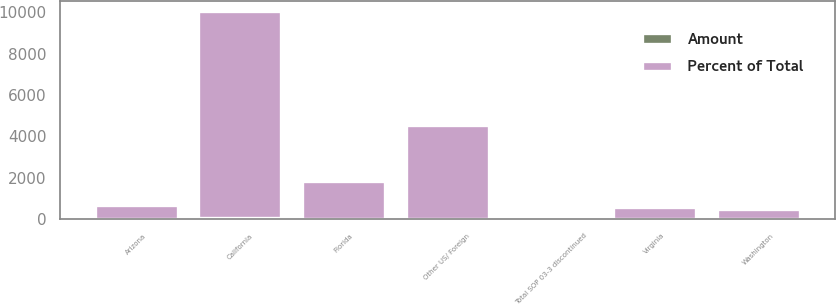<chart> <loc_0><loc_0><loc_500><loc_500><stacked_bar_chart><ecel><fcel>California<fcel>Florida<fcel>Arizona<fcel>Virginia<fcel>Washington<fcel>Other US/ Foreign<fcel>Total SOP 03-3 discontinued<nl><fcel>Percent of Total<fcel>9987<fcel>1831<fcel>666<fcel>580<fcel>492<fcel>4541<fcel>100<nl><fcel>Amount<fcel>55.2<fcel>10.1<fcel>3.7<fcel>3.2<fcel>2.7<fcel>25.1<fcel>100<nl></chart> 